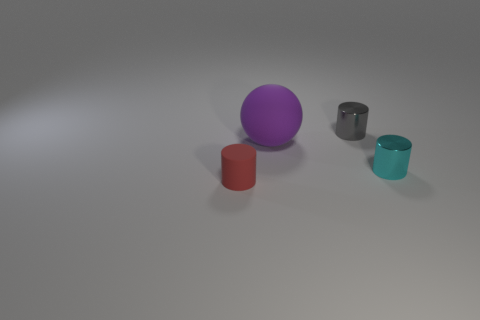Subtract all tiny shiny cylinders. How many cylinders are left? 1 Subtract all cylinders. How many objects are left? 1 Add 1 small blue matte objects. How many objects exist? 5 Subtract all gray cylinders. How many cylinders are left? 2 Subtract 1 balls. How many balls are left? 0 Subtract all yellow cylinders. Subtract all green balls. How many cylinders are left? 3 Subtract all purple matte spheres. Subtract all objects. How many objects are left? 2 Add 4 cyan objects. How many cyan objects are left? 5 Add 2 big matte things. How many big matte things exist? 3 Subtract 0 yellow cubes. How many objects are left? 4 